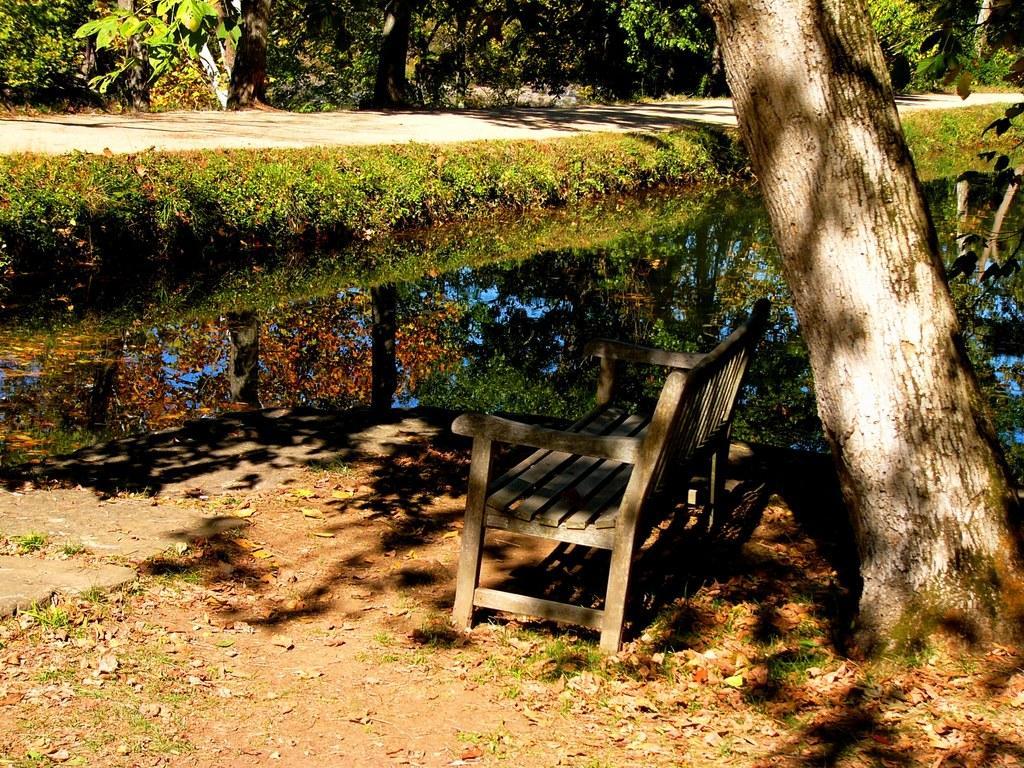Please provide a concise description of this image. In this picture I can see a bench, there is water, there are plants and trees. 